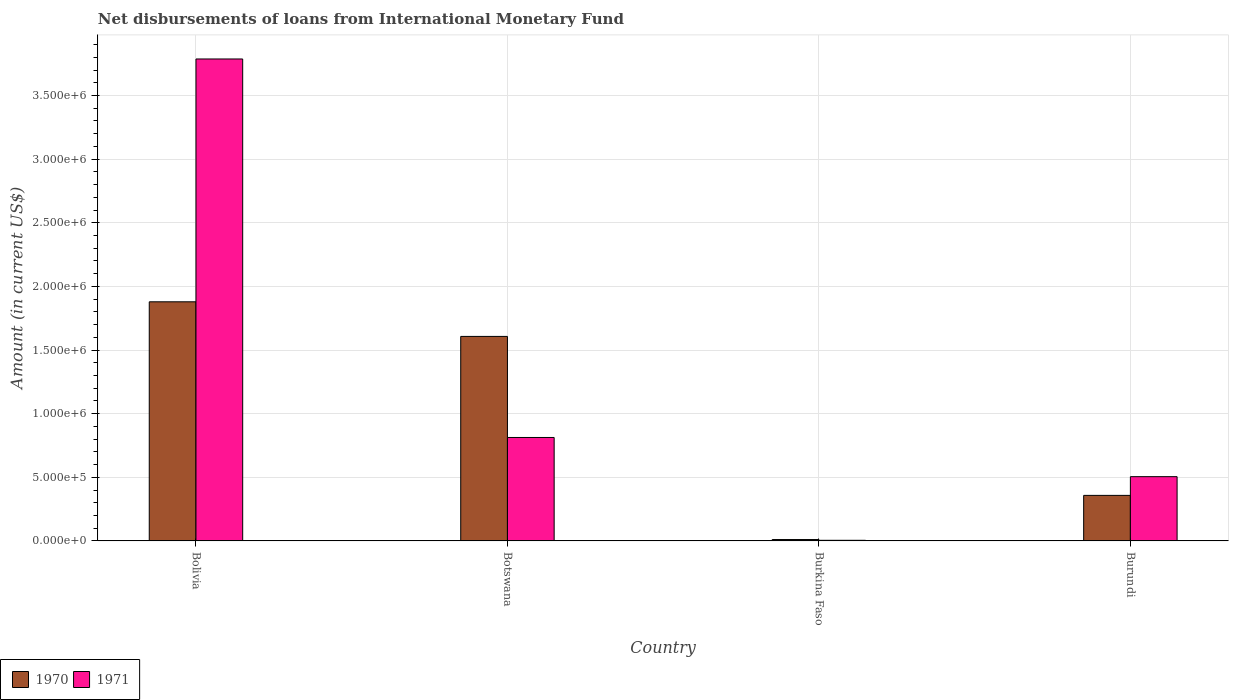How many different coloured bars are there?
Offer a terse response. 2. How many groups of bars are there?
Give a very brief answer. 4. Are the number of bars on each tick of the X-axis equal?
Offer a terse response. Yes. How many bars are there on the 2nd tick from the left?
Provide a short and direct response. 2. What is the label of the 2nd group of bars from the left?
Your answer should be compact. Botswana. What is the amount of loans disbursed in 1971 in Botswana?
Offer a very short reply. 8.13e+05. Across all countries, what is the maximum amount of loans disbursed in 1970?
Offer a terse response. 1.88e+06. In which country was the amount of loans disbursed in 1970 minimum?
Provide a short and direct response. Burkina Faso. What is the total amount of loans disbursed in 1971 in the graph?
Give a very brief answer. 5.11e+06. What is the difference between the amount of loans disbursed in 1971 in Botswana and that in Burkina Faso?
Give a very brief answer. 8.08e+05. What is the difference between the amount of loans disbursed in 1970 in Botswana and the amount of loans disbursed in 1971 in Burundi?
Ensure brevity in your answer.  1.10e+06. What is the average amount of loans disbursed in 1970 per country?
Your response must be concise. 9.64e+05. What is the difference between the amount of loans disbursed of/in 1970 and amount of loans disbursed of/in 1971 in Bolivia?
Offer a very short reply. -1.91e+06. In how many countries, is the amount of loans disbursed in 1970 greater than 3500000 US$?
Offer a terse response. 0. What is the ratio of the amount of loans disbursed in 1970 in Botswana to that in Burundi?
Ensure brevity in your answer.  4.49. Is the amount of loans disbursed in 1970 in Bolivia less than that in Botswana?
Offer a terse response. No. Is the difference between the amount of loans disbursed in 1970 in Bolivia and Botswana greater than the difference between the amount of loans disbursed in 1971 in Bolivia and Botswana?
Offer a very short reply. No. What is the difference between the highest and the second highest amount of loans disbursed in 1970?
Offer a very short reply. 2.72e+05. What is the difference between the highest and the lowest amount of loans disbursed in 1970?
Your response must be concise. 1.87e+06. In how many countries, is the amount of loans disbursed in 1971 greater than the average amount of loans disbursed in 1971 taken over all countries?
Ensure brevity in your answer.  1. What does the 1st bar from the right in Burundi represents?
Keep it short and to the point. 1971. How many bars are there?
Offer a terse response. 8. Are all the bars in the graph horizontal?
Your response must be concise. No. What is the difference between two consecutive major ticks on the Y-axis?
Provide a short and direct response. 5.00e+05. Are the values on the major ticks of Y-axis written in scientific E-notation?
Give a very brief answer. Yes. Where does the legend appear in the graph?
Provide a succinct answer. Bottom left. How many legend labels are there?
Your answer should be compact. 2. What is the title of the graph?
Make the answer very short. Net disbursements of loans from International Monetary Fund. What is the Amount (in current US$) of 1970 in Bolivia?
Offer a terse response. 1.88e+06. What is the Amount (in current US$) in 1971 in Bolivia?
Keep it short and to the point. 3.79e+06. What is the Amount (in current US$) in 1970 in Botswana?
Offer a terse response. 1.61e+06. What is the Amount (in current US$) in 1971 in Botswana?
Offer a terse response. 8.13e+05. What is the Amount (in current US$) of 1970 in Burkina Faso?
Provide a short and direct response. 1.10e+04. What is the Amount (in current US$) of 1971 in Burkina Faso?
Your answer should be very brief. 5000. What is the Amount (in current US$) in 1970 in Burundi?
Give a very brief answer. 3.58e+05. What is the Amount (in current US$) in 1971 in Burundi?
Offer a very short reply. 5.05e+05. Across all countries, what is the maximum Amount (in current US$) of 1970?
Your answer should be very brief. 1.88e+06. Across all countries, what is the maximum Amount (in current US$) in 1971?
Your answer should be very brief. 3.79e+06. Across all countries, what is the minimum Amount (in current US$) in 1970?
Offer a terse response. 1.10e+04. What is the total Amount (in current US$) in 1970 in the graph?
Make the answer very short. 3.86e+06. What is the total Amount (in current US$) in 1971 in the graph?
Give a very brief answer. 5.11e+06. What is the difference between the Amount (in current US$) of 1970 in Bolivia and that in Botswana?
Your response must be concise. 2.72e+05. What is the difference between the Amount (in current US$) of 1971 in Bolivia and that in Botswana?
Your answer should be very brief. 2.97e+06. What is the difference between the Amount (in current US$) of 1970 in Bolivia and that in Burkina Faso?
Your answer should be compact. 1.87e+06. What is the difference between the Amount (in current US$) of 1971 in Bolivia and that in Burkina Faso?
Your answer should be very brief. 3.78e+06. What is the difference between the Amount (in current US$) of 1970 in Bolivia and that in Burundi?
Your response must be concise. 1.52e+06. What is the difference between the Amount (in current US$) in 1971 in Bolivia and that in Burundi?
Keep it short and to the point. 3.28e+06. What is the difference between the Amount (in current US$) in 1970 in Botswana and that in Burkina Faso?
Provide a short and direct response. 1.60e+06. What is the difference between the Amount (in current US$) of 1971 in Botswana and that in Burkina Faso?
Offer a terse response. 8.08e+05. What is the difference between the Amount (in current US$) in 1970 in Botswana and that in Burundi?
Provide a short and direct response. 1.25e+06. What is the difference between the Amount (in current US$) in 1971 in Botswana and that in Burundi?
Give a very brief answer. 3.08e+05. What is the difference between the Amount (in current US$) in 1970 in Burkina Faso and that in Burundi?
Your answer should be compact. -3.47e+05. What is the difference between the Amount (in current US$) of 1971 in Burkina Faso and that in Burundi?
Ensure brevity in your answer.  -5.00e+05. What is the difference between the Amount (in current US$) in 1970 in Bolivia and the Amount (in current US$) in 1971 in Botswana?
Your answer should be very brief. 1.07e+06. What is the difference between the Amount (in current US$) of 1970 in Bolivia and the Amount (in current US$) of 1971 in Burkina Faso?
Your response must be concise. 1.87e+06. What is the difference between the Amount (in current US$) of 1970 in Bolivia and the Amount (in current US$) of 1971 in Burundi?
Your answer should be compact. 1.37e+06. What is the difference between the Amount (in current US$) in 1970 in Botswana and the Amount (in current US$) in 1971 in Burkina Faso?
Your answer should be compact. 1.60e+06. What is the difference between the Amount (in current US$) of 1970 in Botswana and the Amount (in current US$) of 1971 in Burundi?
Provide a succinct answer. 1.10e+06. What is the difference between the Amount (in current US$) in 1970 in Burkina Faso and the Amount (in current US$) in 1971 in Burundi?
Provide a succinct answer. -4.94e+05. What is the average Amount (in current US$) in 1970 per country?
Your answer should be very brief. 9.64e+05. What is the average Amount (in current US$) of 1971 per country?
Your response must be concise. 1.28e+06. What is the difference between the Amount (in current US$) in 1970 and Amount (in current US$) in 1971 in Bolivia?
Offer a very short reply. -1.91e+06. What is the difference between the Amount (in current US$) of 1970 and Amount (in current US$) of 1971 in Botswana?
Your response must be concise. 7.94e+05. What is the difference between the Amount (in current US$) of 1970 and Amount (in current US$) of 1971 in Burkina Faso?
Your response must be concise. 6000. What is the difference between the Amount (in current US$) in 1970 and Amount (in current US$) in 1971 in Burundi?
Your answer should be very brief. -1.47e+05. What is the ratio of the Amount (in current US$) in 1970 in Bolivia to that in Botswana?
Make the answer very short. 1.17. What is the ratio of the Amount (in current US$) of 1971 in Bolivia to that in Botswana?
Ensure brevity in your answer.  4.66. What is the ratio of the Amount (in current US$) in 1970 in Bolivia to that in Burkina Faso?
Offer a terse response. 170.82. What is the ratio of the Amount (in current US$) of 1971 in Bolivia to that in Burkina Faso?
Your response must be concise. 757.4. What is the ratio of the Amount (in current US$) of 1970 in Bolivia to that in Burundi?
Your answer should be compact. 5.25. What is the ratio of the Amount (in current US$) in 1971 in Bolivia to that in Burundi?
Offer a terse response. 7.5. What is the ratio of the Amount (in current US$) of 1970 in Botswana to that in Burkina Faso?
Offer a terse response. 146.09. What is the ratio of the Amount (in current US$) in 1971 in Botswana to that in Burkina Faso?
Your answer should be very brief. 162.6. What is the ratio of the Amount (in current US$) in 1970 in Botswana to that in Burundi?
Provide a short and direct response. 4.49. What is the ratio of the Amount (in current US$) in 1971 in Botswana to that in Burundi?
Your response must be concise. 1.61. What is the ratio of the Amount (in current US$) of 1970 in Burkina Faso to that in Burundi?
Ensure brevity in your answer.  0.03. What is the ratio of the Amount (in current US$) of 1971 in Burkina Faso to that in Burundi?
Your response must be concise. 0.01. What is the difference between the highest and the second highest Amount (in current US$) of 1970?
Make the answer very short. 2.72e+05. What is the difference between the highest and the second highest Amount (in current US$) of 1971?
Offer a very short reply. 2.97e+06. What is the difference between the highest and the lowest Amount (in current US$) of 1970?
Your answer should be very brief. 1.87e+06. What is the difference between the highest and the lowest Amount (in current US$) in 1971?
Give a very brief answer. 3.78e+06. 